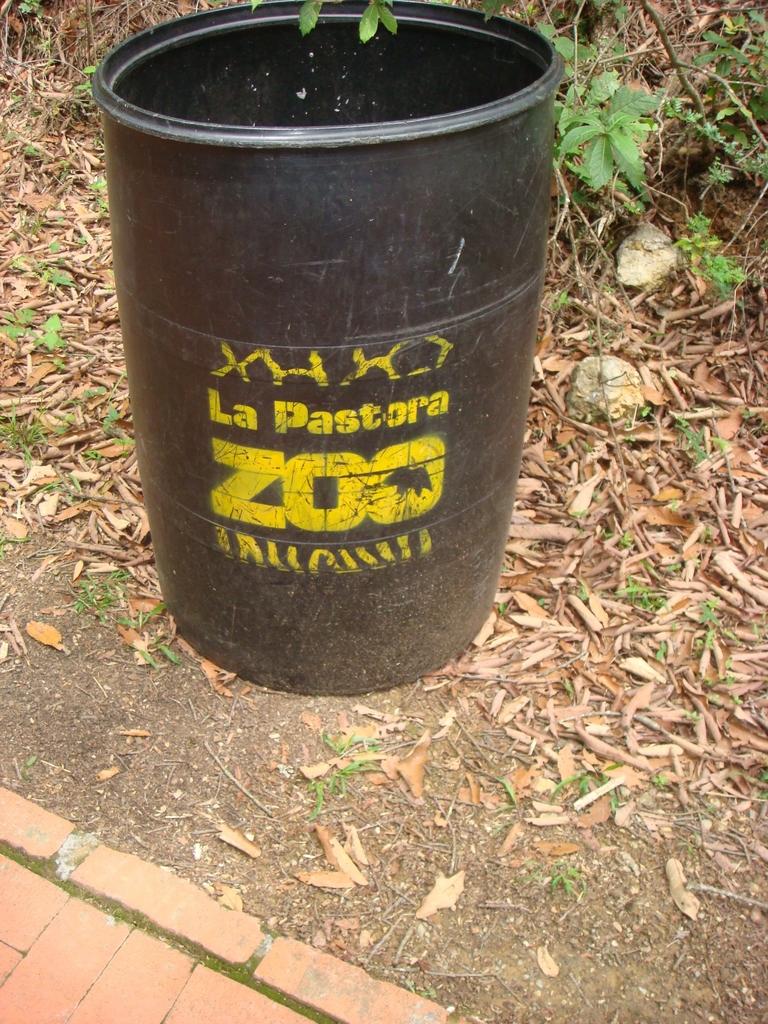Which zoo is this located in?
Provide a short and direct response. La pastora. What kind of place is la pastora?
Provide a succinct answer. Zoo. 